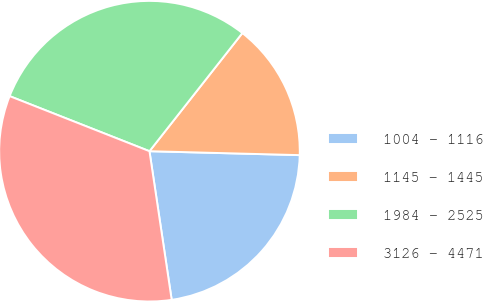Convert chart to OTSL. <chart><loc_0><loc_0><loc_500><loc_500><pie_chart><fcel>1004 - 1116<fcel>1145 - 1445<fcel>1984 - 2525<fcel>3126 - 4471<nl><fcel>22.22%<fcel>14.81%<fcel>29.63%<fcel>33.33%<nl></chart> 